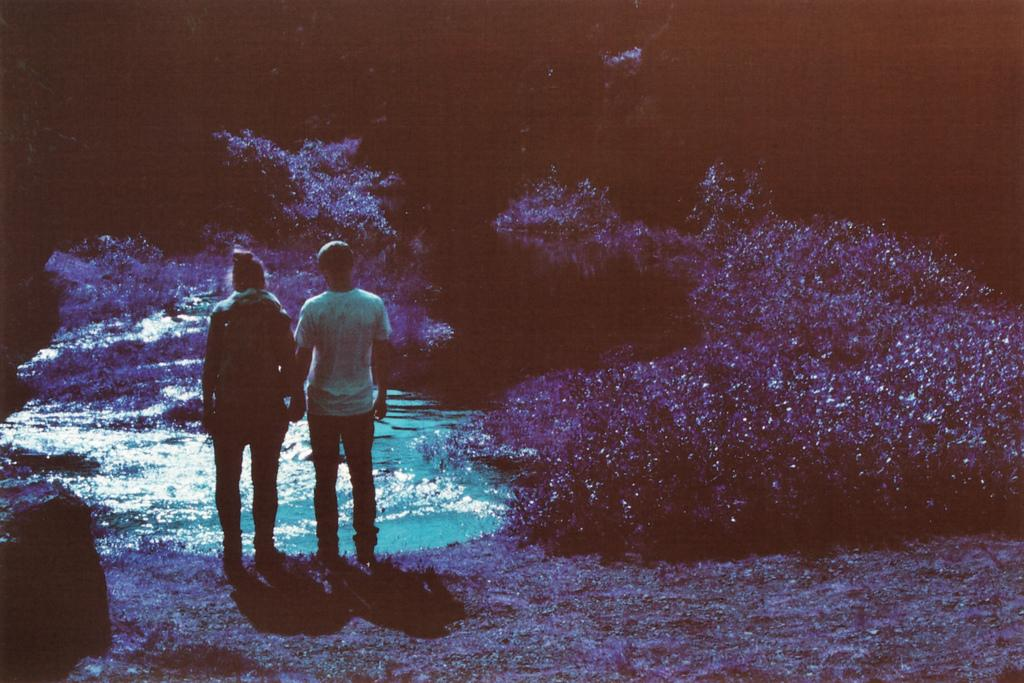How many people are in the image? There are two persons in the image. What is visible in the image besides the people? Water, plants, and trees are visible in the image. What is the color of the background in the image? The background of the image is dark. How many letters are being pushed by the persons in the image? There are no letters present in the image, and no indication that the persons are pushing anything. 